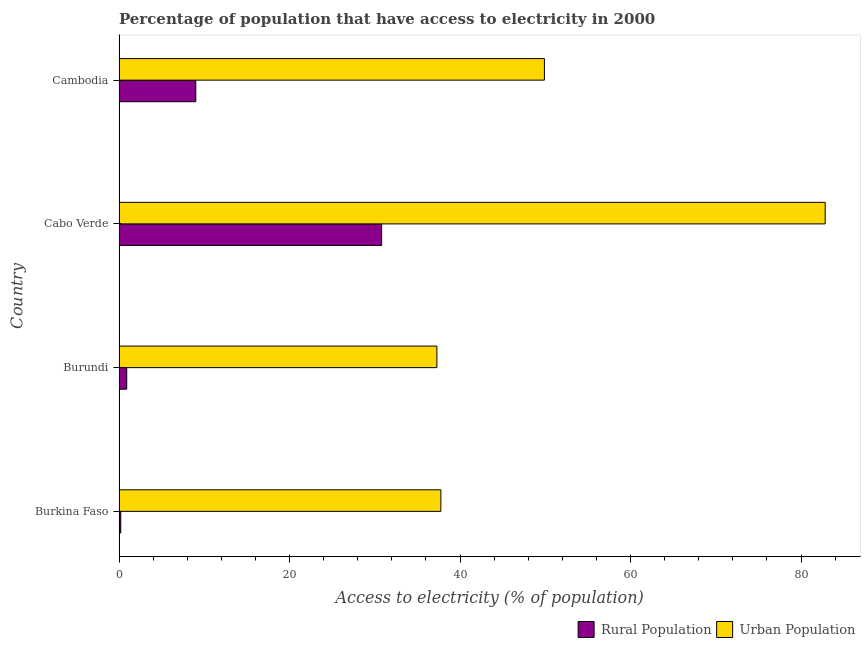Are the number of bars per tick equal to the number of legend labels?
Your answer should be compact. Yes. Are the number of bars on each tick of the Y-axis equal?
Provide a succinct answer. Yes. How many bars are there on the 3rd tick from the top?
Your response must be concise. 2. How many bars are there on the 4th tick from the bottom?
Offer a very short reply. 2. What is the label of the 4th group of bars from the top?
Your answer should be very brief. Burkina Faso. What is the percentage of urban population having access to electricity in Cambodia?
Ensure brevity in your answer.  49.89. Across all countries, what is the maximum percentage of urban population having access to electricity?
Keep it short and to the point. 82.83. Across all countries, what is the minimum percentage of urban population having access to electricity?
Give a very brief answer. 37.28. In which country was the percentage of urban population having access to electricity maximum?
Provide a succinct answer. Cabo Verde. In which country was the percentage of rural population having access to electricity minimum?
Provide a succinct answer. Burkina Faso. What is the total percentage of rural population having access to electricity in the graph?
Give a very brief answer. 40.9. What is the difference between the percentage of rural population having access to electricity in Burundi and that in Cabo Verde?
Ensure brevity in your answer.  -29.9. What is the difference between the percentage of urban population having access to electricity in Burundi and the percentage of rural population having access to electricity in Burkina Faso?
Give a very brief answer. 37.08. What is the average percentage of rural population having access to electricity per country?
Make the answer very short. 10.22. What is the difference between the percentage of rural population having access to electricity and percentage of urban population having access to electricity in Cambodia?
Your answer should be very brief. -40.89. In how many countries, is the percentage of urban population having access to electricity greater than 44 %?
Your answer should be compact. 2. What is the ratio of the percentage of urban population having access to electricity in Burundi to that in Cambodia?
Provide a succinct answer. 0.75. What is the difference between the highest and the second highest percentage of rural population having access to electricity?
Offer a very short reply. 21.8. What is the difference between the highest and the lowest percentage of rural population having access to electricity?
Provide a succinct answer. 30.6. In how many countries, is the percentage of urban population having access to electricity greater than the average percentage of urban population having access to electricity taken over all countries?
Make the answer very short. 1. Is the sum of the percentage of rural population having access to electricity in Burkina Faso and Cabo Verde greater than the maximum percentage of urban population having access to electricity across all countries?
Make the answer very short. No. What does the 2nd bar from the top in Burundi represents?
Offer a terse response. Rural Population. What does the 2nd bar from the bottom in Burundi represents?
Your answer should be compact. Urban Population. Are all the bars in the graph horizontal?
Offer a very short reply. Yes. What is the difference between two consecutive major ticks on the X-axis?
Provide a short and direct response. 20. Does the graph contain any zero values?
Make the answer very short. No. How many legend labels are there?
Make the answer very short. 2. What is the title of the graph?
Provide a short and direct response. Percentage of population that have access to electricity in 2000. What is the label or title of the X-axis?
Your response must be concise. Access to electricity (% of population). What is the label or title of the Y-axis?
Ensure brevity in your answer.  Country. What is the Access to electricity (% of population) in Urban Population in Burkina Faso?
Offer a very short reply. 37.75. What is the Access to electricity (% of population) of Urban Population in Burundi?
Offer a terse response. 37.28. What is the Access to electricity (% of population) of Rural Population in Cabo Verde?
Offer a terse response. 30.8. What is the Access to electricity (% of population) in Urban Population in Cabo Verde?
Provide a succinct answer. 82.83. What is the Access to electricity (% of population) of Rural Population in Cambodia?
Ensure brevity in your answer.  9. What is the Access to electricity (% of population) in Urban Population in Cambodia?
Your answer should be compact. 49.89. Across all countries, what is the maximum Access to electricity (% of population) in Rural Population?
Give a very brief answer. 30.8. Across all countries, what is the maximum Access to electricity (% of population) in Urban Population?
Provide a succinct answer. 82.83. Across all countries, what is the minimum Access to electricity (% of population) of Urban Population?
Make the answer very short. 37.28. What is the total Access to electricity (% of population) in Rural Population in the graph?
Your answer should be compact. 40.9. What is the total Access to electricity (% of population) of Urban Population in the graph?
Your answer should be very brief. 207.75. What is the difference between the Access to electricity (% of population) in Urban Population in Burkina Faso and that in Burundi?
Ensure brevity in your answer.  0.47. What is the difference between the Access to electricity (% of population) in Rural Population in Burkina Faso and that in Cabo Verde?
Your response must be concise. -30.6. What is the difference between the Access to electricity (% of population) in Urban Population in Burkina Faso and that in Cabo Verde?
Give a very brief answer. -45.08. What is the difference between the Access to electricity (% of population) of Rural Population in Burkina Faso and that in Cambodia?
Give a very brief answer. -8.8. What is the difference between the Access to electricity (% of population) in Urban Population in Burkina Faso and that in Cambodia?
Your answer should be compact. -12.14. What is the difference between the Access to electricity (% of population) of Rural Population in Burundi and that in Cabo Verde?
Your answer should be very brief. -29.9. What is the difference between the Access to electricity (% of population) of Urban Population in Burundi and that in Cabo Verde?
Your response must be concise. -45.54. What is the difference between the Access to electricity (% of population) in Urban Population in Burundi and that in Cambodia?
Give a very brief answer. -12.61. What is the difference between the Access to electricity (% of population) in Rural Population in Cabo Verde and that in Cambodia?
Offer a very short reply. 21.8. What is the difference between the Access to electricity (% of population) in Urban Population in Cabo Verde and that in Cambodia?
Make the answer very short. 32.93. What is the difference between the Access to electricity (% of population) of Rural Population in Burkina Faso and the Access to electricity (% of population) of Urban Population in Burundi?
Provide a short and direct response. -37.08. What is the difference between the Access to electricity (% of population) of Rural Population in Burkina Faso and the Access to electricity (% of population) of Urban Population in Cabo Verde?
Provide a short and direct response. -82.63. What is the difference between the Access to electricity (% of population) of Rural Population in Burkina Faso and the Access to electricity (% of population) of Urban Population in Cambodia?
Make the answer very short. -49.69. What is the difference between the Access to electricity (% of population) in Rural Population in Burundi and the Access to electricity (% of population) in Urban Population in Cabo Verde?
Keep it short and to the point. -81.93. What is the difference between the Access to electricity (% of population) in Rural Population in Burundi and the Access to electricity (% of population) in Urban Population in Cambodia?
Your response must be concise. -48.99. What is the difference between the Access to electricity (% of population) in Rural Population in Cabo Verde and the Access to electricity (% of population) in Urban Population in Cambodia?
Keep it short and to the point. -19.09. What is the average Access to electricity (% of population) of Rural Population per country?
Your response must be concise. 10.22. What is the average Access to electricity (% of population) in Urban Population per country?
Keep it short and to the point. 51.94. What is the difference between the Access to electricity (% of population) of Rural Population and Access to electricity (% of population) of Urban Population in Burkina Faso?
Give a very brief answer. -37.55. What is the difference between the Access to electricity (% of population) of Rural Population and Access to electricity (% of population) of Urban Population in Burundi?
Offer a terse response. -36.38. What is the difference between the Access to electricity (% of population) in Rural Population and Access to electricity (% of population) in Urban Population in Cabo Verde?
Offer a terse response. -52.03. What is the difference between the Access to electricity (% of population) in Rural Population and Access to electricity (% of population) in Urban Population in Cambodia?
Your answer should be compact. -40.89. What is the ratio of the Access to electricity (% of population) in Rural Population in Burkina Faso to that in Burundi?
Make the answer very short. 0.22. What is the ratio of the Access to electricity (% of population) of Urban Population in Burkina Faso to that in Burundi?
Your response must be concise. 1.01. What is the ratio of the Access to electricity (% of population) of Rural Population in Burkina Faso to that in Cabo Verde?
Ensure brevity in your answer.  0.01. What is the ratio of the Access to electricity (% of population) in Urban Population in Burkina Faso to that in Cabo Verde?
Your response must be concise. 0.46. What is the ratio of the Access to electricity (% of population) of Rural Population in Burkina Faso to that in Cambodia?
Your response must be concise. 0.02. What is the ratio of the Access to electricity (% of population) of Urban Population in Burkina Faso to that in Cambodia?
Keep it short and to the point. 0.76. What is the ratio of the Access to electricity (% of population) of Rural Population in Burundi to that in Cabo Verde?
Your answer should be very brief. 0.03. What is the ratio of the Access to electricity (% of population) of Urban Population in Burundi to that in Cabo Verde?
Provide a short and direct response. 0.45. What is the ratio of the Access to electricity (% of population) of Rural Population in Burundi to that in Cambodia?
Your answer should be very brief. 0.1. What is the ratio of the Access to electricity (% of population) in Urban Population in Burundi to that in Cambodia?
Offer a very short reply. 0.75. What is the ratio of the Access to electricity (% of population) of Rural Population in Cabo Verde to that in Cambodia?
Your response must be concise. 3.42. What is the ratio of the Access to electricity (% of population) in Urban Population in Cabo Verde to that in Cambodia?
Your answer should be compact. 1.66. What is the difference between the highest and the second highest Access to electricity (% of population) of Rural Population?
Offer a very short reply. 21.8. What is the difference between the highest and the second highest Access to electricity (% of population) of Urban Population?
Your response must be concise. 32.93. What is the difference between the highest and the lowest Access to electricity (% of population) in Rural Population?
Give a very brief answer. 30.6. What is the difference between the highest and the lowest Access to electricity (% of population) of Urban Population?
Provide a short and direct response. 45.54. 